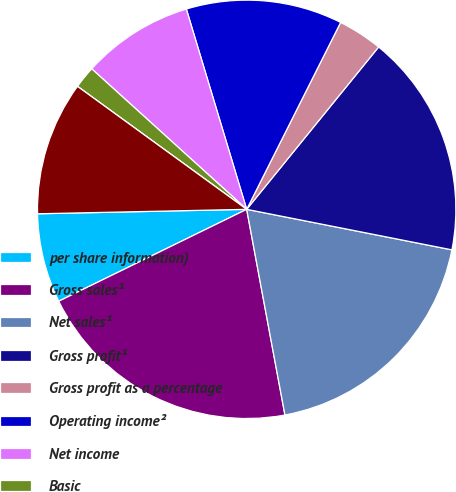Convert chart to OTSL. <chart><loc_0><loc_0><loc_500><loc_500><pie_chart><fcel>per share information)<fcel>Gross sales¹<fcel>Net sales¹<fcel>Gross profit¹<fcel>Gross profit as a percentage<fcel>Operating income²<fcel>Net income<fcel>Basic<fcel>Diluted<fcel>Cash cash equivalents and<nl><fcel>6.9%<fcel>20.69%<fcel>18.97%<fcel>17.24%<fcel>3.45%<fcel>12.07%<fcel>8.62%<fcel>1.72%<fcel>0.0%<fcel>10.34%<nl></chart> 